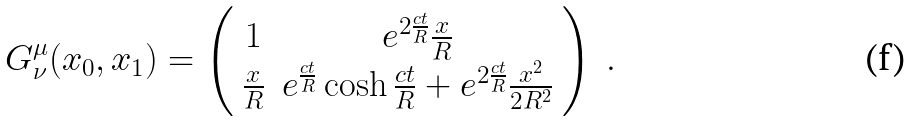<formula> <loc_0><loc_0><loc_500><loc_500>G ^ { \mu } _ { \nu } ( x _ { 0 } , x _ { 1 } ) = \left ( \begin{array} { c c } 1 & e ^ { 2 \frac { c t } R } \frac { x } { R } \\ \frac { x } { R } & e ^ { \frac { c t } R } \cosh \frac { c t } R + e ^ { 2 \frac { c t } R } \frac { x ^ { 2 } } { 2 R ^ { 2 } } \end{array} \right ) \ .</formula> 